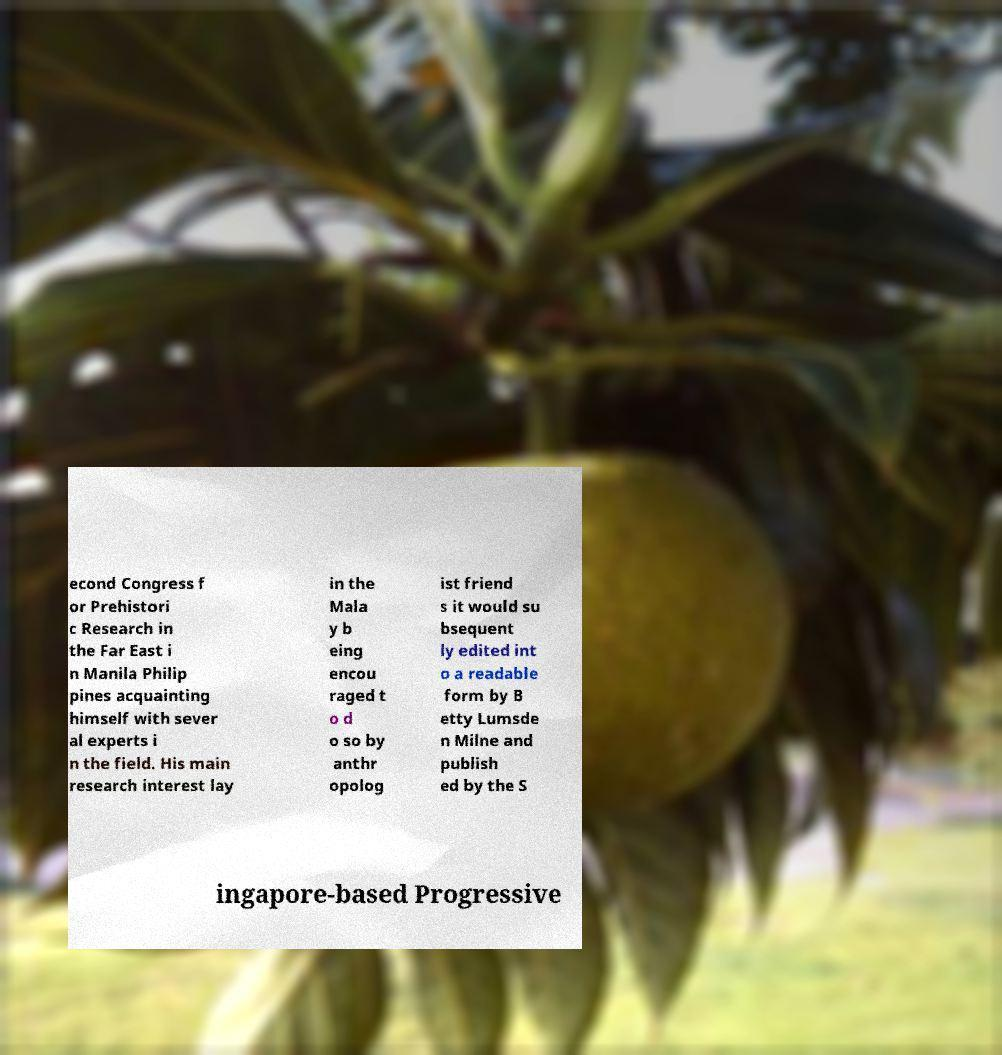Please identify and transcribe the text found in this image. econd Congress f or Prehistori c Research in the Far East i n Manila Philip pines acquainting himself with sever al experts i n the field. His main research interest lay in the Mala y b eing encou raged t o d o so by anthr opolog ist friend s it would su bsequent ly edited int o a readable form by B etty Lumsde n Milne and publish ed by the S ingapore-based Progressive 